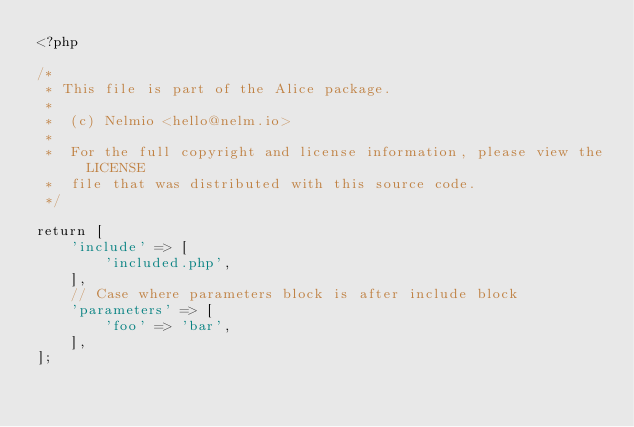Convert code to text. <code><loc_0><loc_0><loc_500><loc_500><_PHP_><?php

/*
 * This file is part of the Alice package.
 *
 *  (c) Nelmio <hello@nelm.io>
 *
 *  For the full copyright and license information, please view the LICENSE
 *  file that was distributed with this source code.
 */

return [
    'include' => [
        'included.php',
    ],
    // Case where parameters block is after include block
    'parameters' => [
        'foo' => 'bar',
    ],
];
</code> 